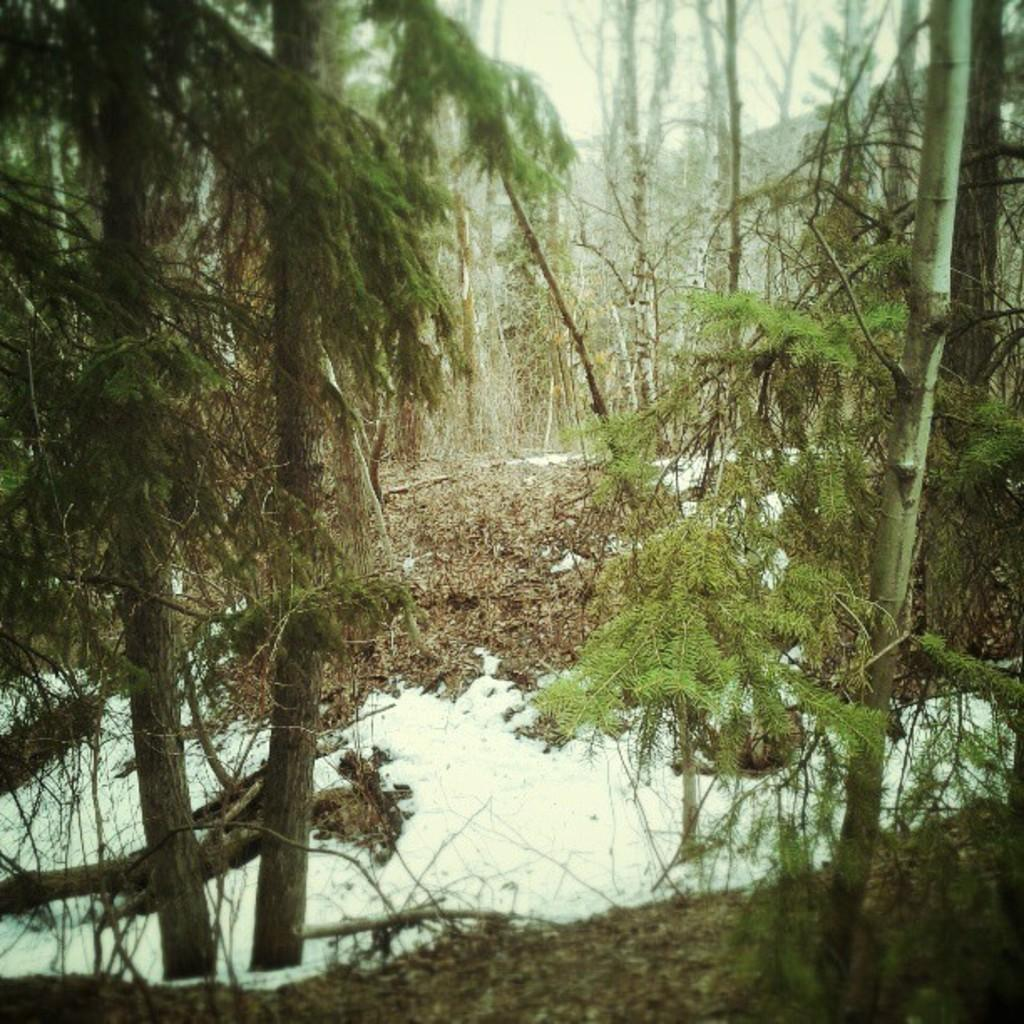What type of environment is depicted in the image? The image appears to be taken in a forest. What can be seen in the forest? There is a group of trees in the image. What type of vegetation is present in the image? Grass is present in the image. What is the weather like in the image? Snow is visible at the bottom of the image, indicating a cold or snowy environment. How many giants are visible in the image? There are no giants present in the image; it depicts a forest scene with trees, grass, and snow. What type of pies are being served in the image? There are no pies present in the image; it is a forest scene with natural elements. 